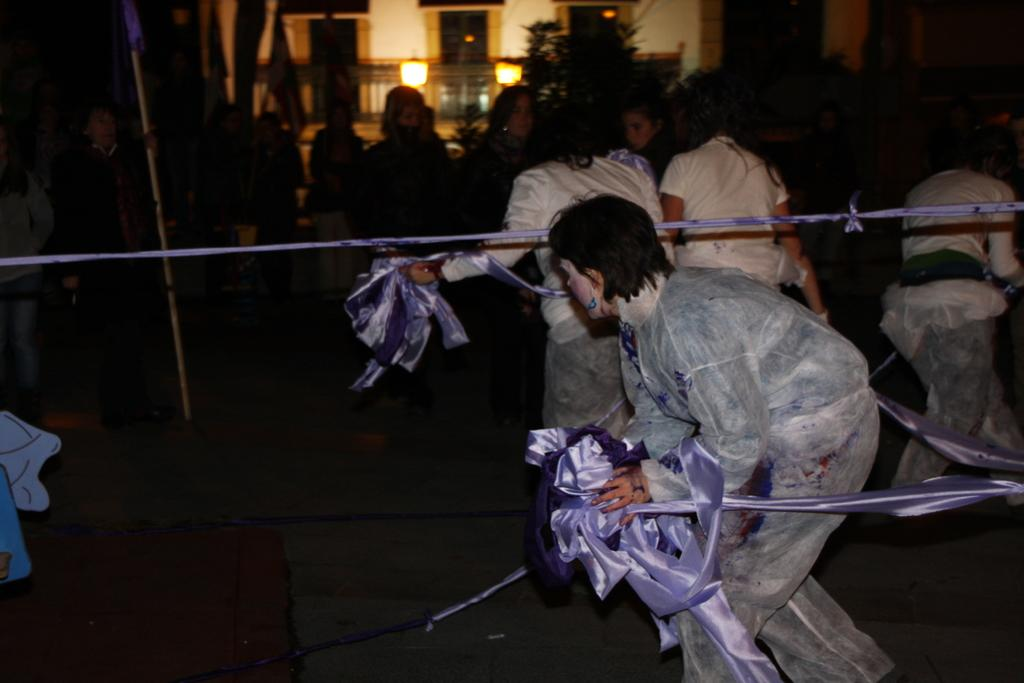Where is the woman located in the image? The woman is on the right side of the image. What is the woman doing in the image? The woman is walking in the image. What is the woman holding in the image? The woman is holding a ribbon in the image. What is the woman wearing in the image? The woman is wearing a coat in the image. What else can be seen in the image besides the woman? There are people walking in the middle of the image, and there are lights on the building in the image. Can you tell me how the woman is talking to her brother in the image? There is no mention of a brother in the image, so we cannot determine if the woman is talking to her brother or anyone else. 